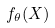Convert formula to latex. <formula><loc_0><loc_0><loc_500><loc_500>f _ { \theta } ( X )</formula> 